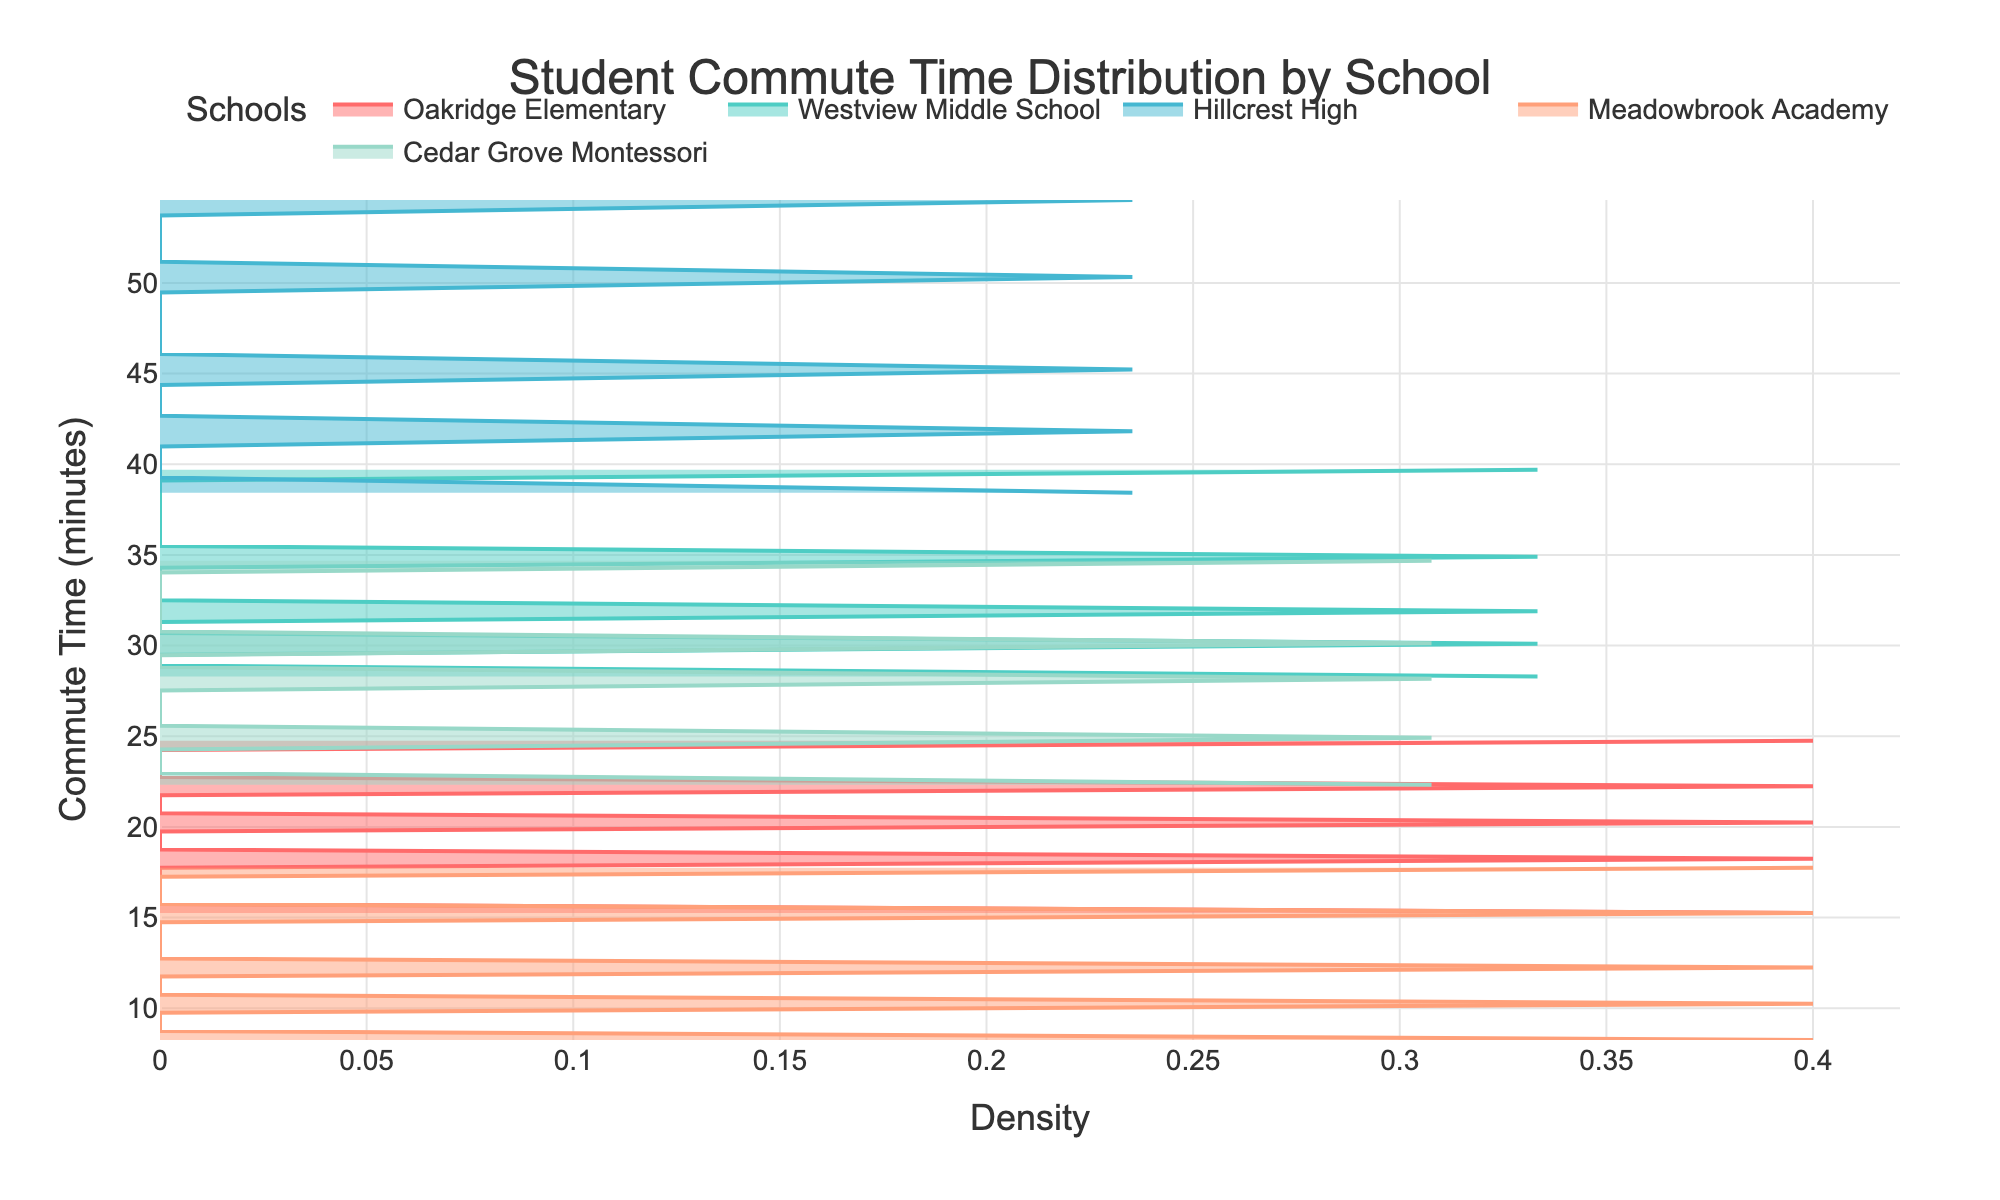What is the title of the plot? The title is displayed at the top of the plot and provides a summary of what the plot is about. By looking at the title, we can understand that the plot is showing the distribution of students' commute times to various local schools.
Answer: Student Commute Time Distribution by School Which color represents Oakridge Elementary on the plot? Each school is represented by a different color in the plot. Oakridge Elementary is the first school in the list, and hence its color is the first in the color palette.
Answer: Red What is the range of commute times for Hillcrest High? To determine the range, we look at the y-axis values where Hillcrest High's distribution is present. The minimum and maximum values on this axis give us the range.
Answer: 38 to 55 minutes Which school has the most spread out commute times? To determine which school has the most spread out commute times, we observe the school whose density curve covers the largest range on the y-axis.
Answer: Hillcrest High Which school has the highest peak density in commute times? The highest peak density can be identified by seeing which school has the highest point on the x-axis for the density values.
Answer: Westview Middle School What is the peak density value for Meadowbrook Academy? To find the peak density value, we identify the highest point of the density curve for Meadowbrook Academy on the x-axis.
Answer: Approximately 0.15 Compare the commute times of Oakridge Elementary and Cedar Grove Montessori. Which school has a longer commute time on average? To compare the average commute times, look at where the peak of the density curves for the two schools are located on the y-axis. The school whose peak is towards the higher side has a longer average commute time.
Answer: Cedar Grove Montessori What is the approximate difference in the maximum commute times between Oakridge Elementary and Westview Middle School? Identify the maximum y-axis value for both schools and subtract the smaller value from the larger one.
Answer: 15 minutes Which school has the smallest range of commute times? The smallest range can be found by identifying the school with the narrowest spread of density along the y-axis.
Answer: Meadowbrook Academy 